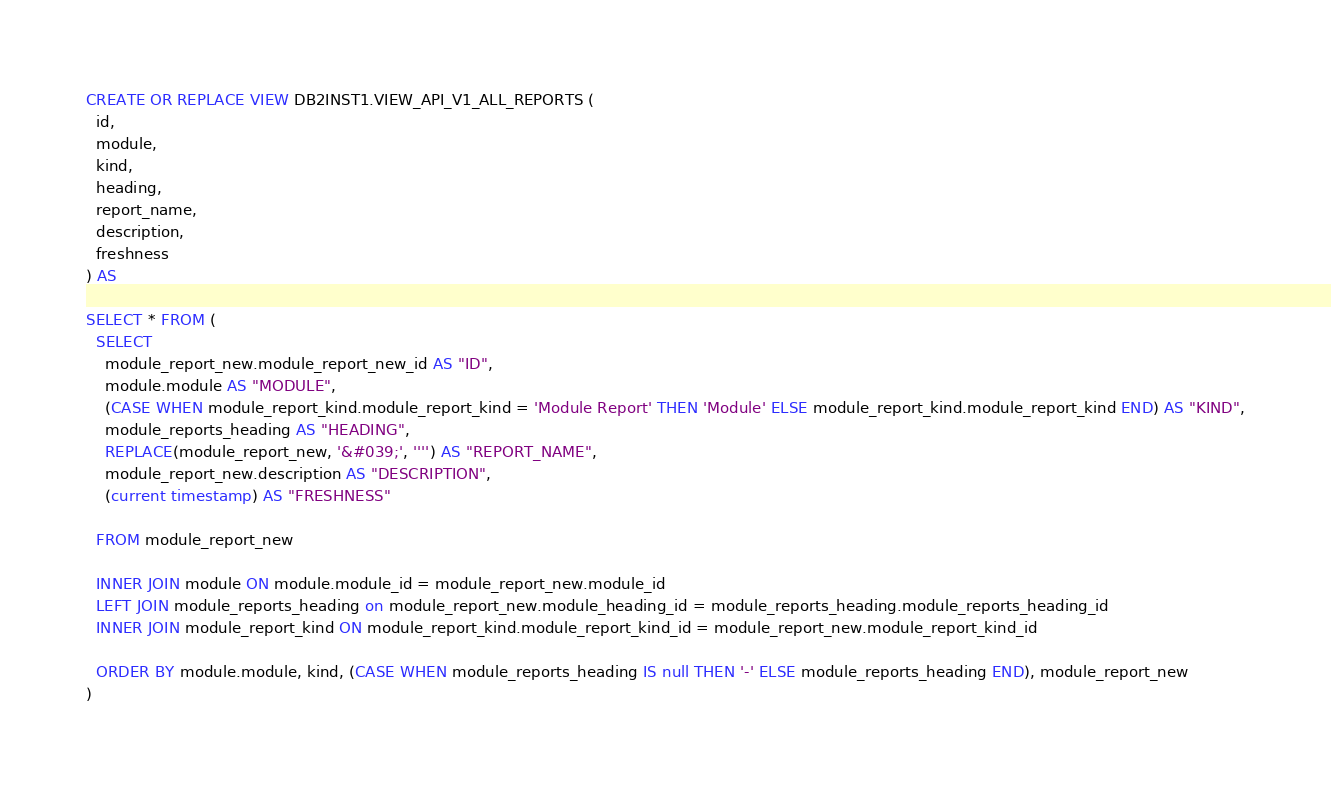Convert code to text. <code><loc_0><loc_0><loc_500><loc_500><_SQL_>CREATE OR REPLACE VIEW DB2INST1.VIEW_API_V1_ALL_REPORTS (
  id,
  module,
  kind,
  heading,
  report_name,
  description,
  freshness
) AS

SELECT * FROM (
  SELECT
    module_report_new.module_report_new_id AS "ID",
    module.module AS "MODULE",
    (CASE WHEN module_report_kind.module_report_kind = 'Module Report' THEN 'Module' ELSE module_report_kind.module_report_kind END) AS "KIND",
    module_reports_heading AS "HEADING",
    REPLACE(module_report_new, '&#039;', '''') AS "REPORT_NAME",
    module_report_new.description AS "DESCRIPTION",
    (current timestamp) AS "FRESHNESS"

  FROM module_report_new

  INNER JOIN module ON module.module_id = module_report_new.module_id
  LEFT JOIN module_reports_heading on module_report_new.module_heading_id = module_reports_heading.module_reports_heading_id
  INNER JOIN module_report_kind ON module_report_kind.module_report_kind_id = module_report_new.module_report_kind_id

  ORDER BY module.module, kind, (CASE WHEN module_reports_heading IS null THEN '-' ELSE module_reports_heading END), module_report_new
)
</code> 